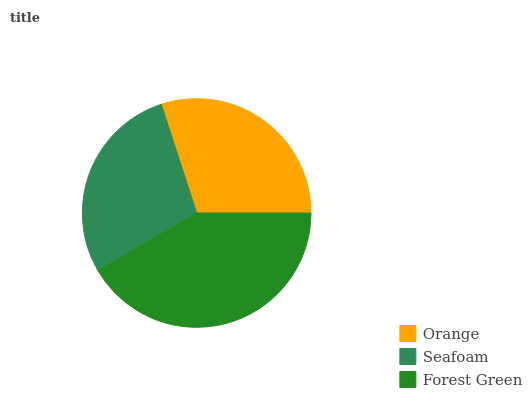Is Seafoam the minimum?
Answer yes or no. Yes. Is Forest Green the maximum?
Answer yes or no. Yes. Is Forest Green the minimum?
Answer yes or no. No. Is Seafoam the maximum?
Answer yes or no. No. Is Forest Green greater than Seafoam?
Answer yes or no. Yes. Is Seafoam less than Forest Green?
Answer yes or no. Yes. Is Seafoam greater than Forest Green?
Answer yes or no. No. Is Forest Green less than Seafoam?
Answer yes or no. No. Is Orange the high median?
Answer yes or no. Yes. Is Orange the low median?
Answer yes or no. Yes. Is Seafoam the high median?
Answer yes or no. No. Is Seafoam the low median?
Answer yes or no. No. 